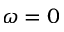Convert formula to latex. <formula><loc_0><loc_0><loc_500><loc_500>\omega = 0</formula> 